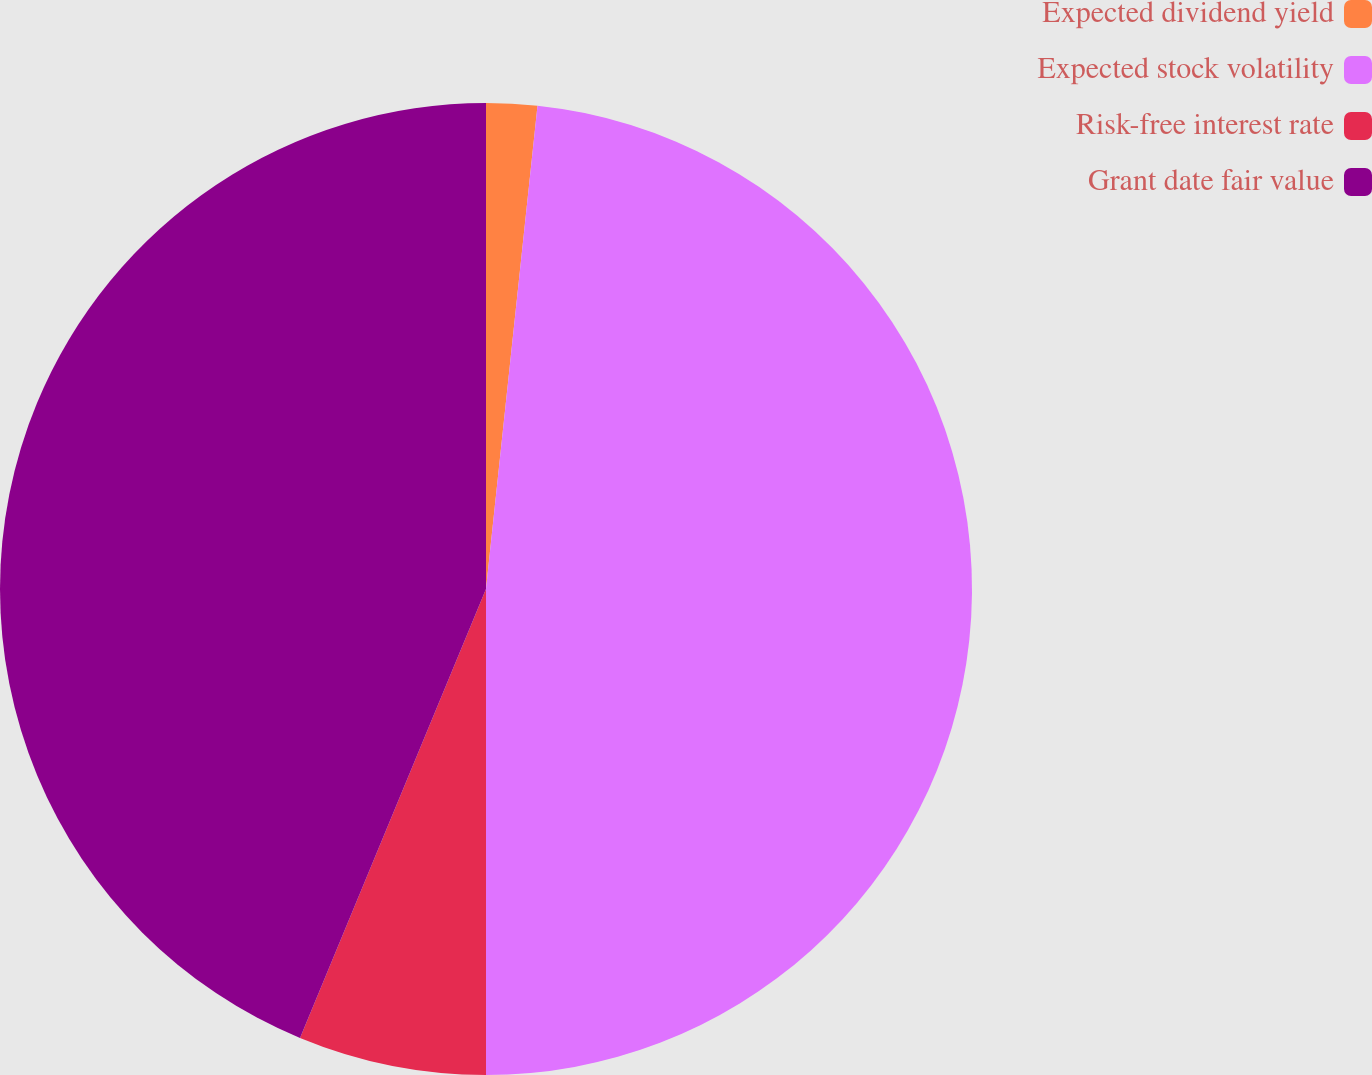Convert chart. <chart><loc_0><loc_0><loc_500><loc_500><pie_chart><fcel>Expected dividend yield<fcel>Expected stock volatility<fcel>Risk-free interest rate<fcel>Grant date fair value<nl><fcel>1.69%<fcel>48.31%<fcel>6.25%<fcel>43.75%<nl></chart> 